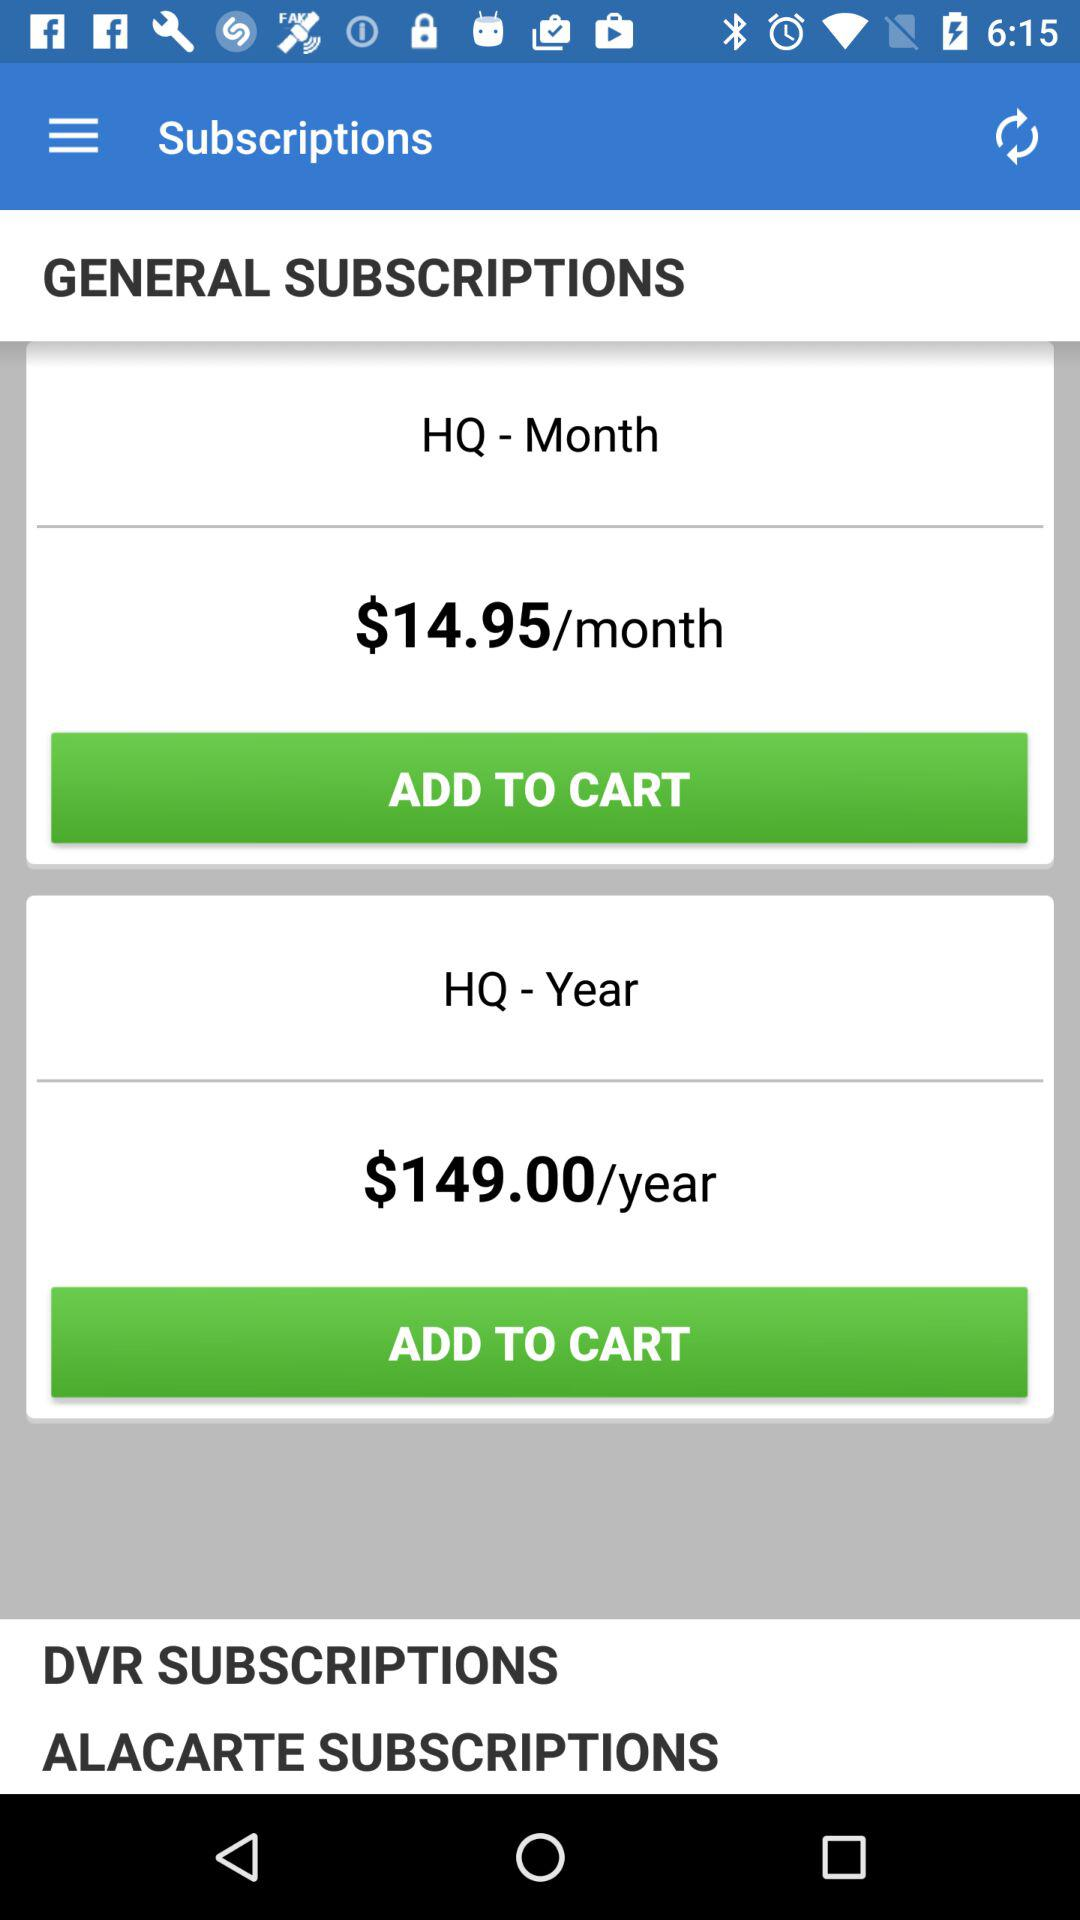How many more subscription options are there for HQ than for DVR?
Answer the question using a single word or phrase. 2 